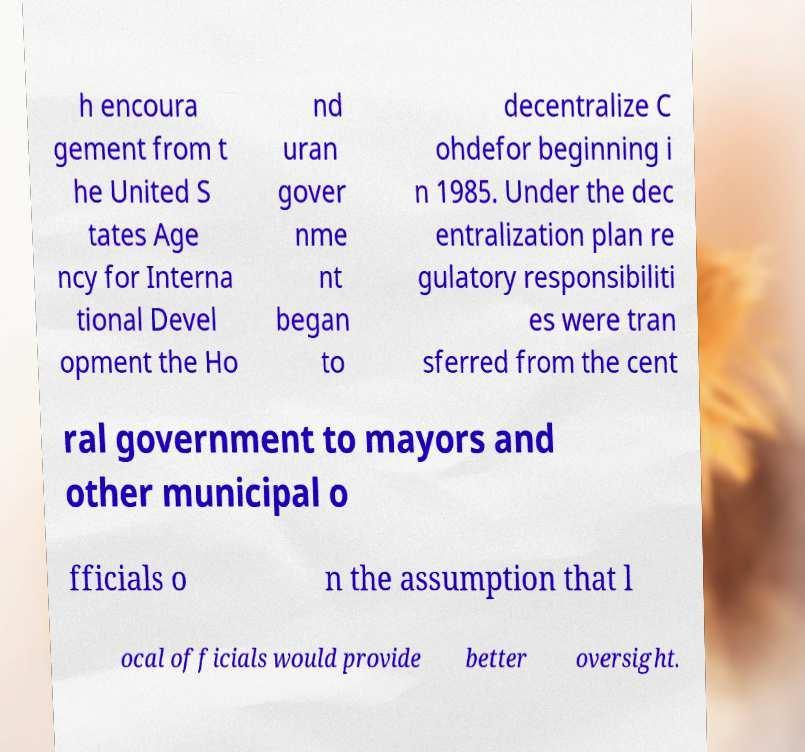Please identify and transcribe the text found in this image. h encoura gement from t he United S tates Age ncy for Interna tional Devel opment the Ho nd uran gover nme nt began to decentralize C ohdefor beginning i n 1985. Under the dec entralization plan re gulatory responsibiliti es were tran sferred from the cent ral government to mayors and other municipal o fficials o n the assumption that l ocal officials would provide better oversight. 